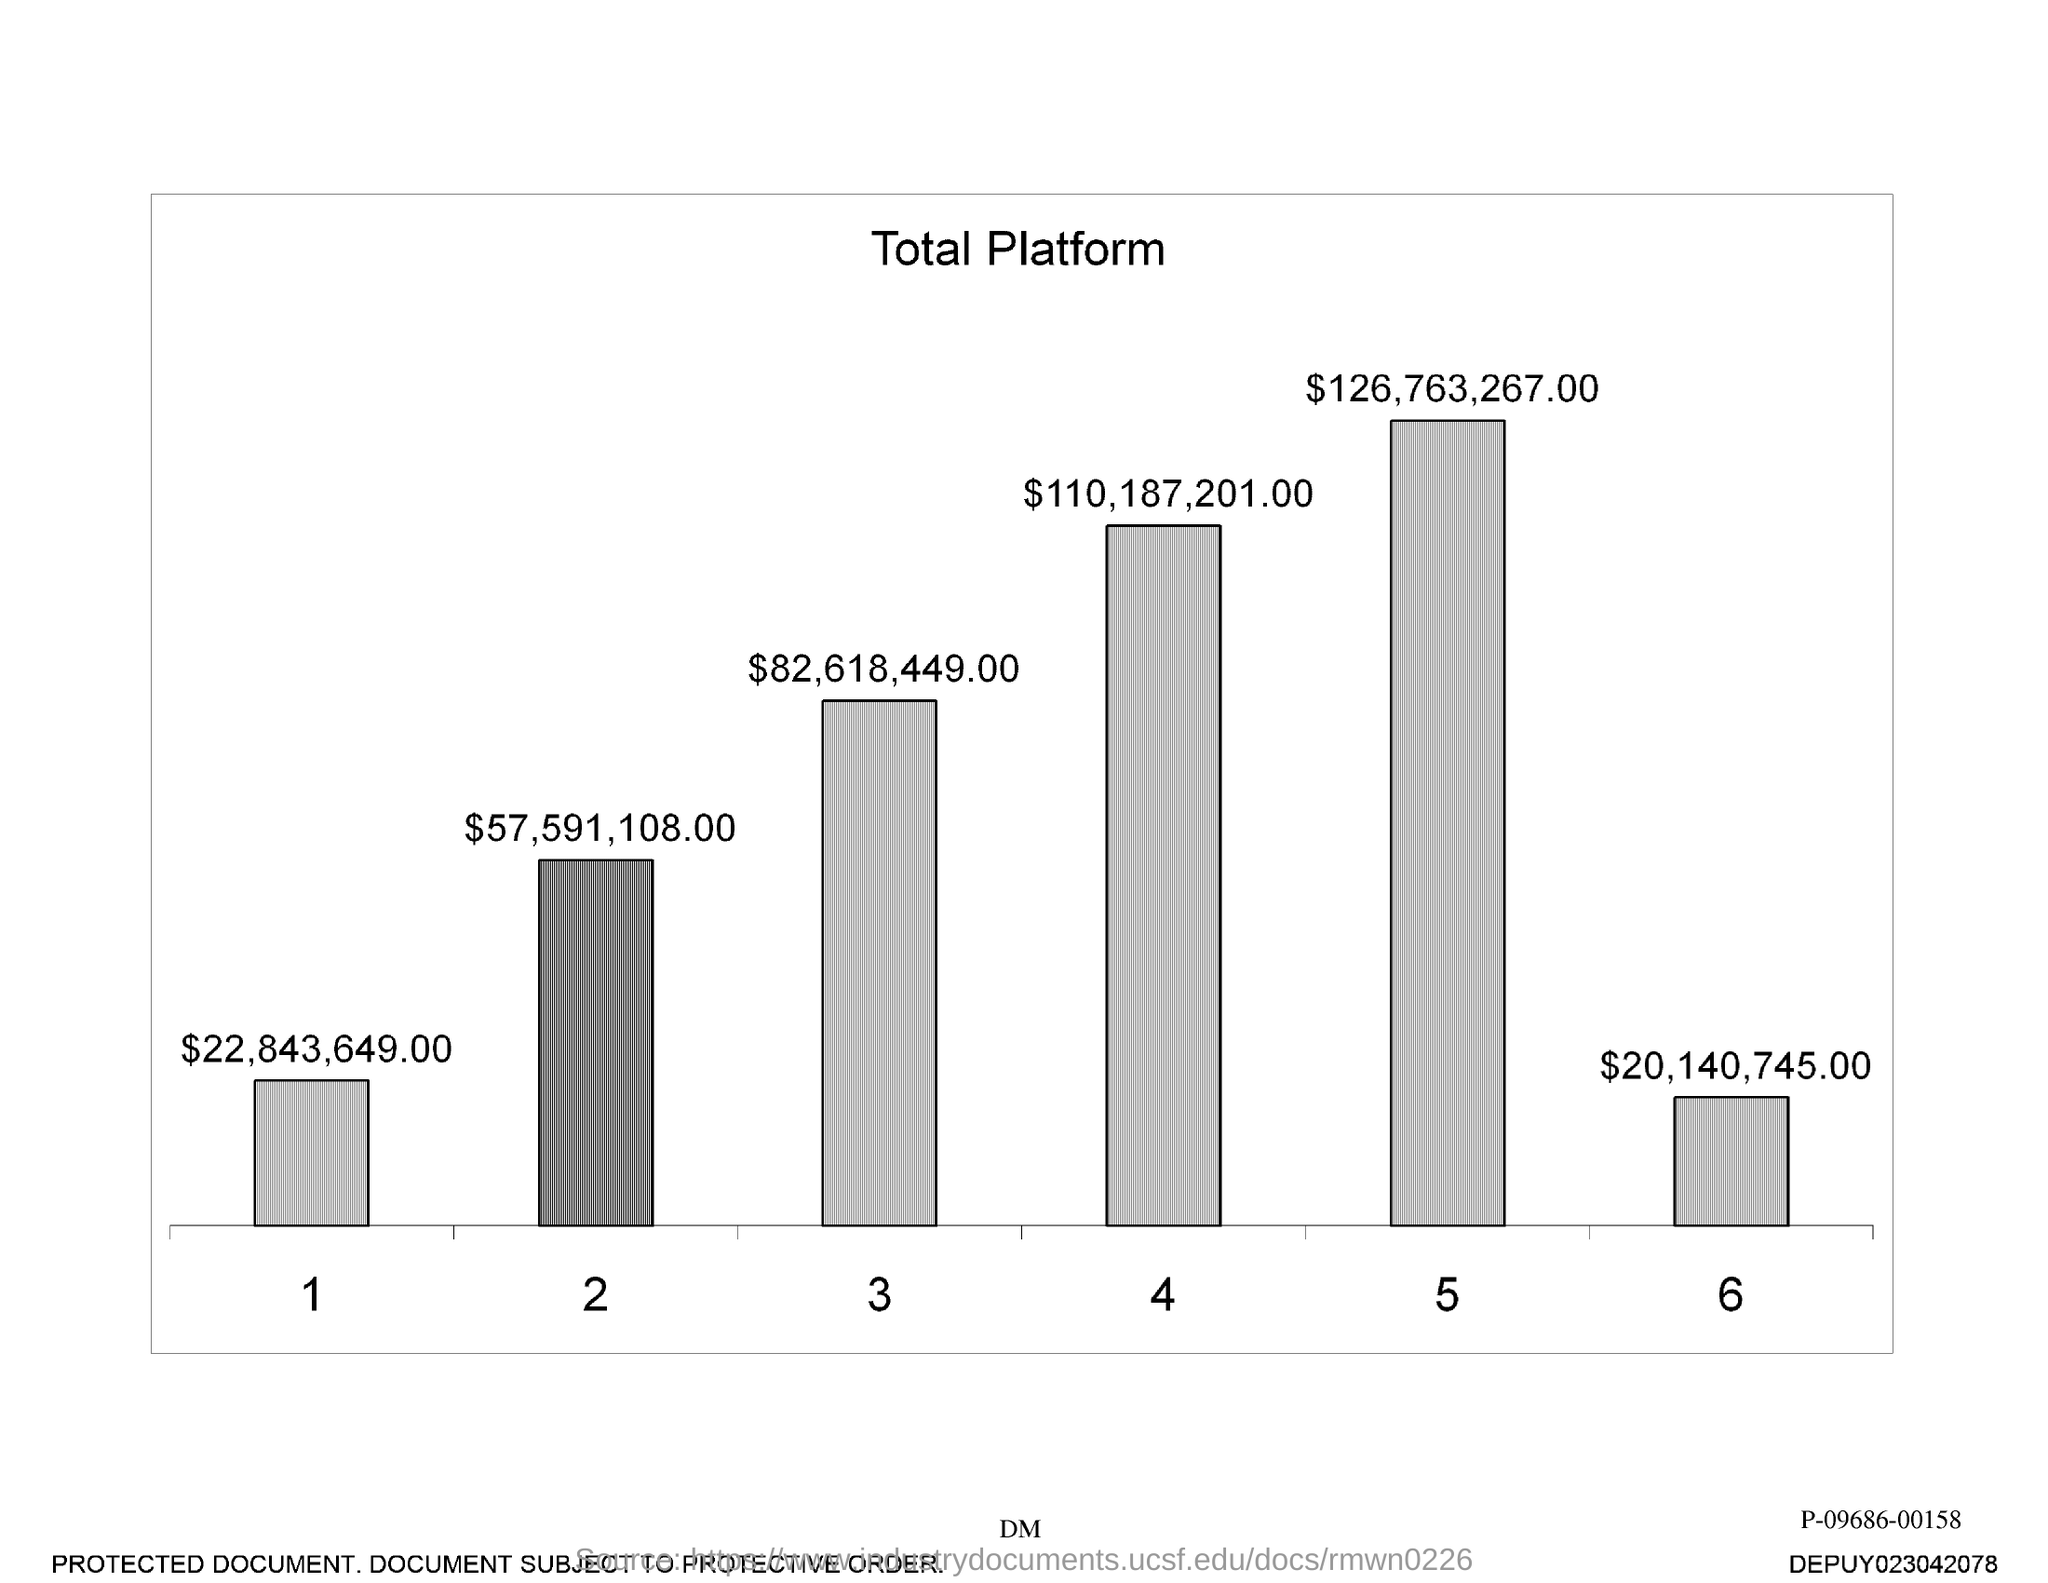List a handful of essential elements in this visual. The title given is 'Total Platform.' The value of the bar 3 is approximately $82,618,449.00. 